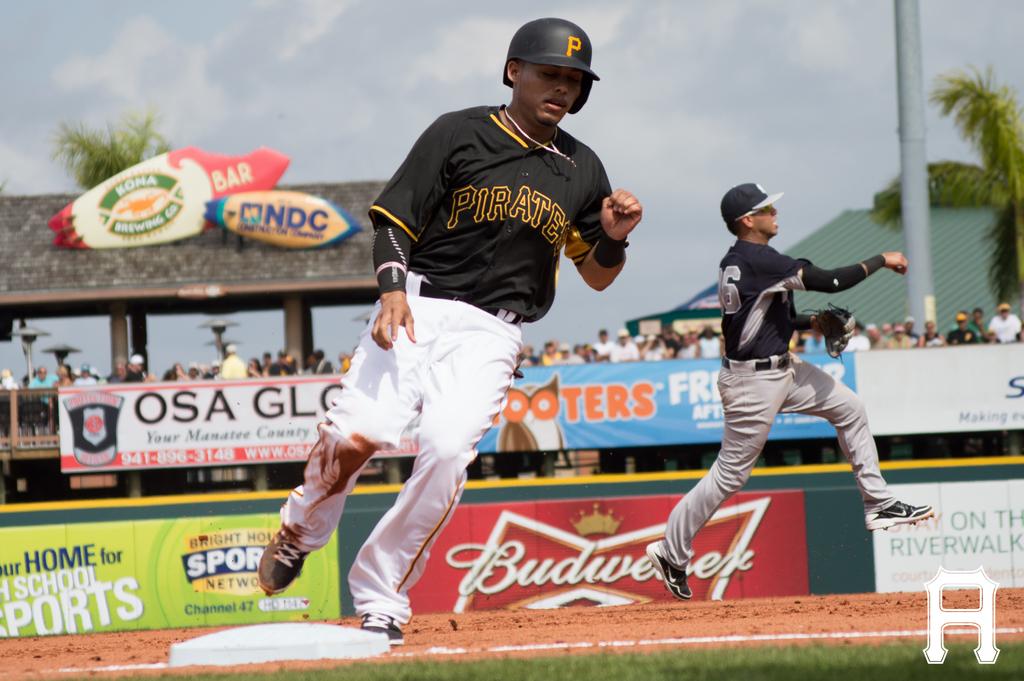What beer is sponsoring this event?
Keep it short and to the point. Budweiser. 